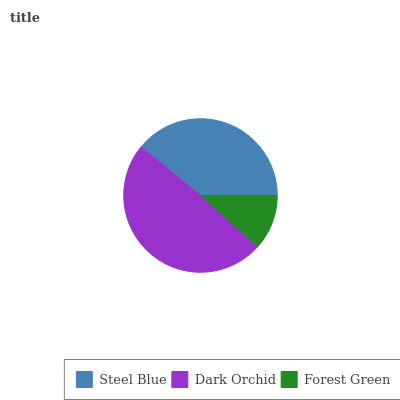Is Forest Green the minimum?
Answer yes or no. Yes. Is Dark Orchid the maximum?
Answer yes or no. Yes. Is Dark Orchid the minimum?
Answer yes or no. No. Is Forest Green the maximum?
Answer yes or no. No. Is Dark Orchid greater than Forest Green?
Answer yes or no. Yes. Is Forest Green less than Dark Orchid?
Answer yes or no. Yes. Is Forest Green greater than Dark Orchid?
Answer yes or no. No. Is Dark Orchid less than Forest Green?
Answer yes or no. No. Is Steel Blue the high median?
Answer yes or no. Yes. Is Steel Blue the low median?
Answer yes or no. Yes. Is Forest Green the high median?
Answer yes or no. No. Is Dark Orchid the low median?
Answer yes or no. No. 